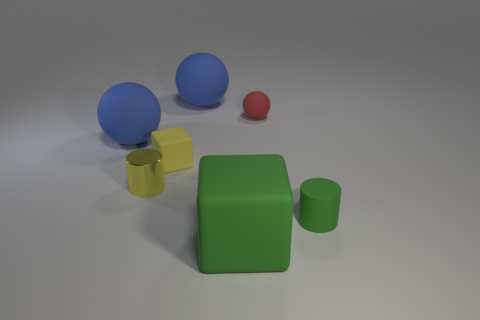Is there any other thing that is the same color as the small shiny cylinder?
Ensure brevity in your answer.  Yes. Is the size of the metallic thing the same as the green block?
Your answer should be very brief. No. How many things are either blue spheres that are on the right side of the tiny yellow rubber block or small things that are behind the small yellow shiny cylinder?
Ensure brevity in your answer.  3. What is the material of the blue object that is in front of the tiny red thing to the right of the large green object?
Your response must be concise. Rubber. What number of other things are there of the same material as the red sphere
Keep it short and to the point. 5. Is the small green object the same shape as the metal thing?
Your response must be concise. Yes. There is a rubber cube that is in front of the shiny cylinder; what is its size?
Offer a very short reply. Large. There is a yellow rubber object; is its size the same as the green object behind the large green rubber thing?
Provide a succinct answer. Yes. Are there fewer small shiny objects that are to the left of the yellow cylinder than tiny red balls?
Offer a very short reply. Yes. What material is the yellow thing that is the same shape as the big green rubber thing?
Provide a short and direct response. Rubber. 